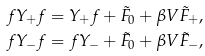<formula> <loc_0><loc_0><loc_500><loc_500>f Y _ { + } f = Y _ { + } f + \tilde { F } _ { 0 } + \beta V \tilde { F } _ { + } , \\ f Y _ { - } f = f Y _ { - } + \tilde { F } _ { 0 } + \beta V \tilde { F } _ { - } ,</formula> 